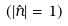<formula> <loc_0><loc_0><loc_500><loc_500>( | \hat { n } | = 1 )</formula> 